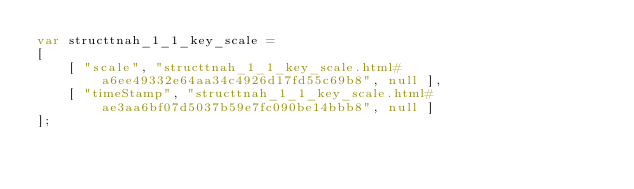Convert code to text. <code><loc_0><loc_0><loc_500><loc_500><_JavaScript_>var structtnah_1_1_key_scale =
[
    [ "scale", "structtnah_1_1_key_scale.html#a6ee49332e64aa34c4926d17fd55c69b8", null ],
    [ "timeStamp", "structtnah_1_1_key_scale.html#ae3aa6bf07d5037b59e7fc090be14bbb8", null ]
];</code> 